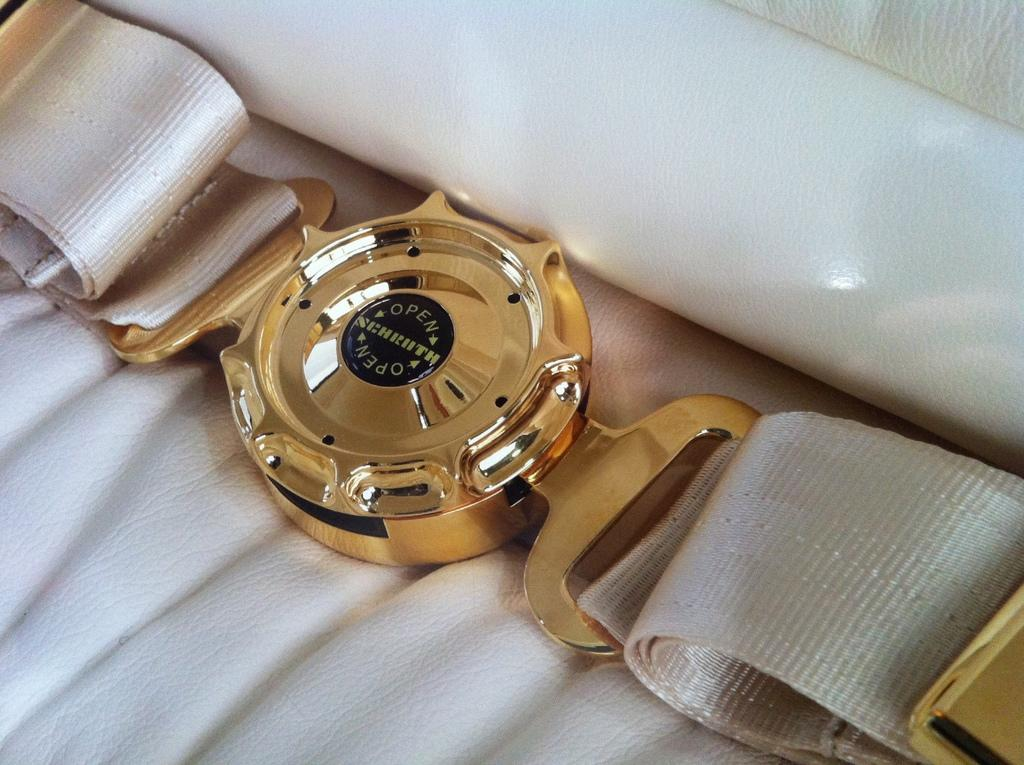Provide a one-sentence caption for the provided image. A gold watch streched out on a white cloth and the watch has the word open on it. 